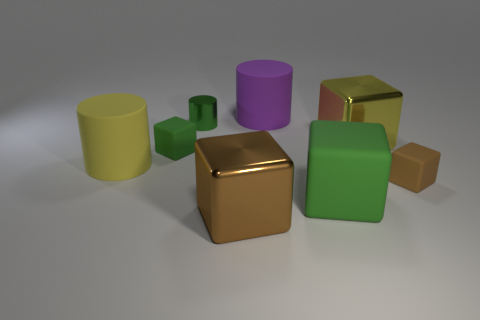How many cubes are either brown metallic objects or metallic things?
Offer a terse response. 2. There is a small green object that is the same shape as the yellow metallic object; what material is it?
Keep it short and to the point. Rubber. What size is the yellow object that is the same material as the big brown object?
Your answer should be compact. Large. There is a brown thing on the right side of the brown metallic block; is it the same shape as the big thing left of the small metal object?
Ensure brevity in your answer.  No. What is the color of the small cylinder that is made of the same material as the big brown thing?
Your answer should be compact. Green. There is a yellow thing in front of the big yellow metal cube; is its size the same as the rubber cylinder that is right of the green shiny object?
Your response must be concise. Yes. What is the shape of the metal thing that is both on the left side of the purple cylinder and in front of the small green metal cylinder?
Offer a terse response. Cube. Is there a big purple cylinder that has the same material as the purple thing?
Provide a succinct answer. No. What material is the other tiny object that is the same color as the tiny shiny thing?
Your answer should be compact. Rubber. Do the green thing that is to the right of the big purple object and the small thing on the right side of the large green object have the same material?
Ensure brevity in your answer.  Yes. 